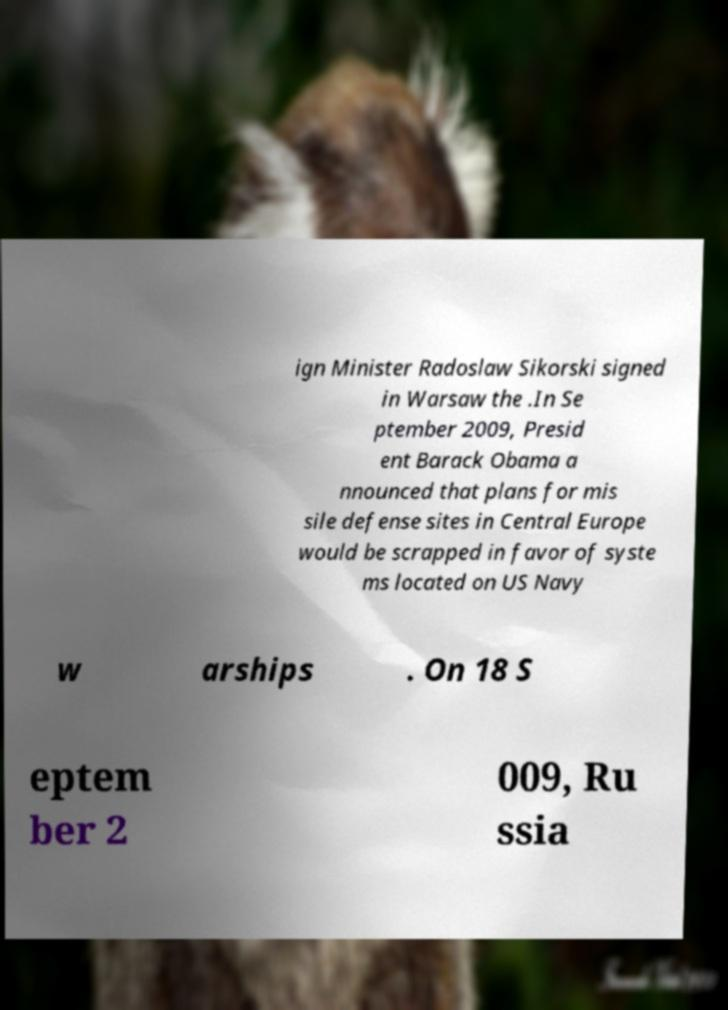I need the written content from this picture converted into text. Can you do that? ign Minister Radoslaw Sikorski signed in Warsaw the .In Se ptember 2009, Presid ent Barack Obama a nnounced that plans for mis sile defense sites in Central Europe would be scrapped in favor of syste ms located on US Navy w arships . On 18 S eptem ber 2 009, Ru ssia 